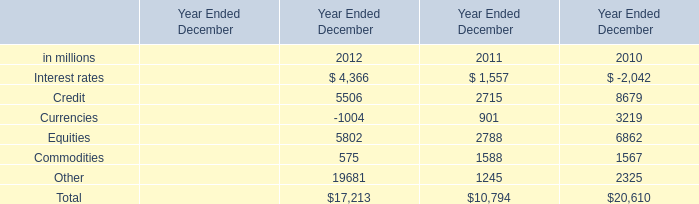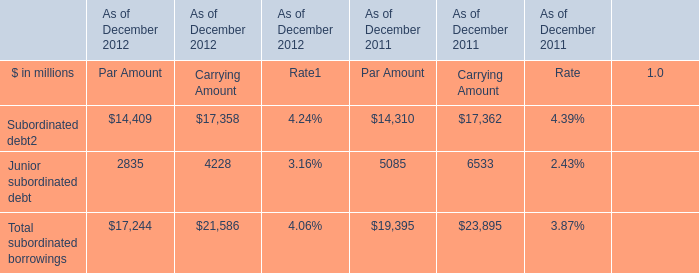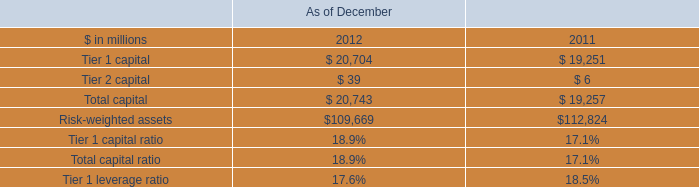What is the growing rate of Equities in the year with the most Commodities? 
Computations: ((5802 - 2788) / 2788)
Answer: 1.08106. 